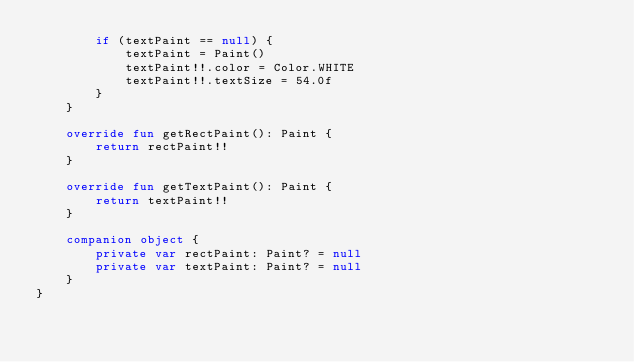<code> <loc_0><loc_0><loc_500><loc_500><_Kotlin_>        if (textPaint == null) {
            textPaint = Paint()
            textPaint!!.color = Color.WHITE
            textPaint!!.textSize = 54.0f
        }
    }

    override fun getRectPaint(): Paint {
        return rectPaint!!
    }

    override fun getTextPaint(): Paint {
        return textPaint!!
    }

    companion object {
        private var rectPaint: Paint? = null
        private var textPaint: Paint? = null
    }
}
</code> 